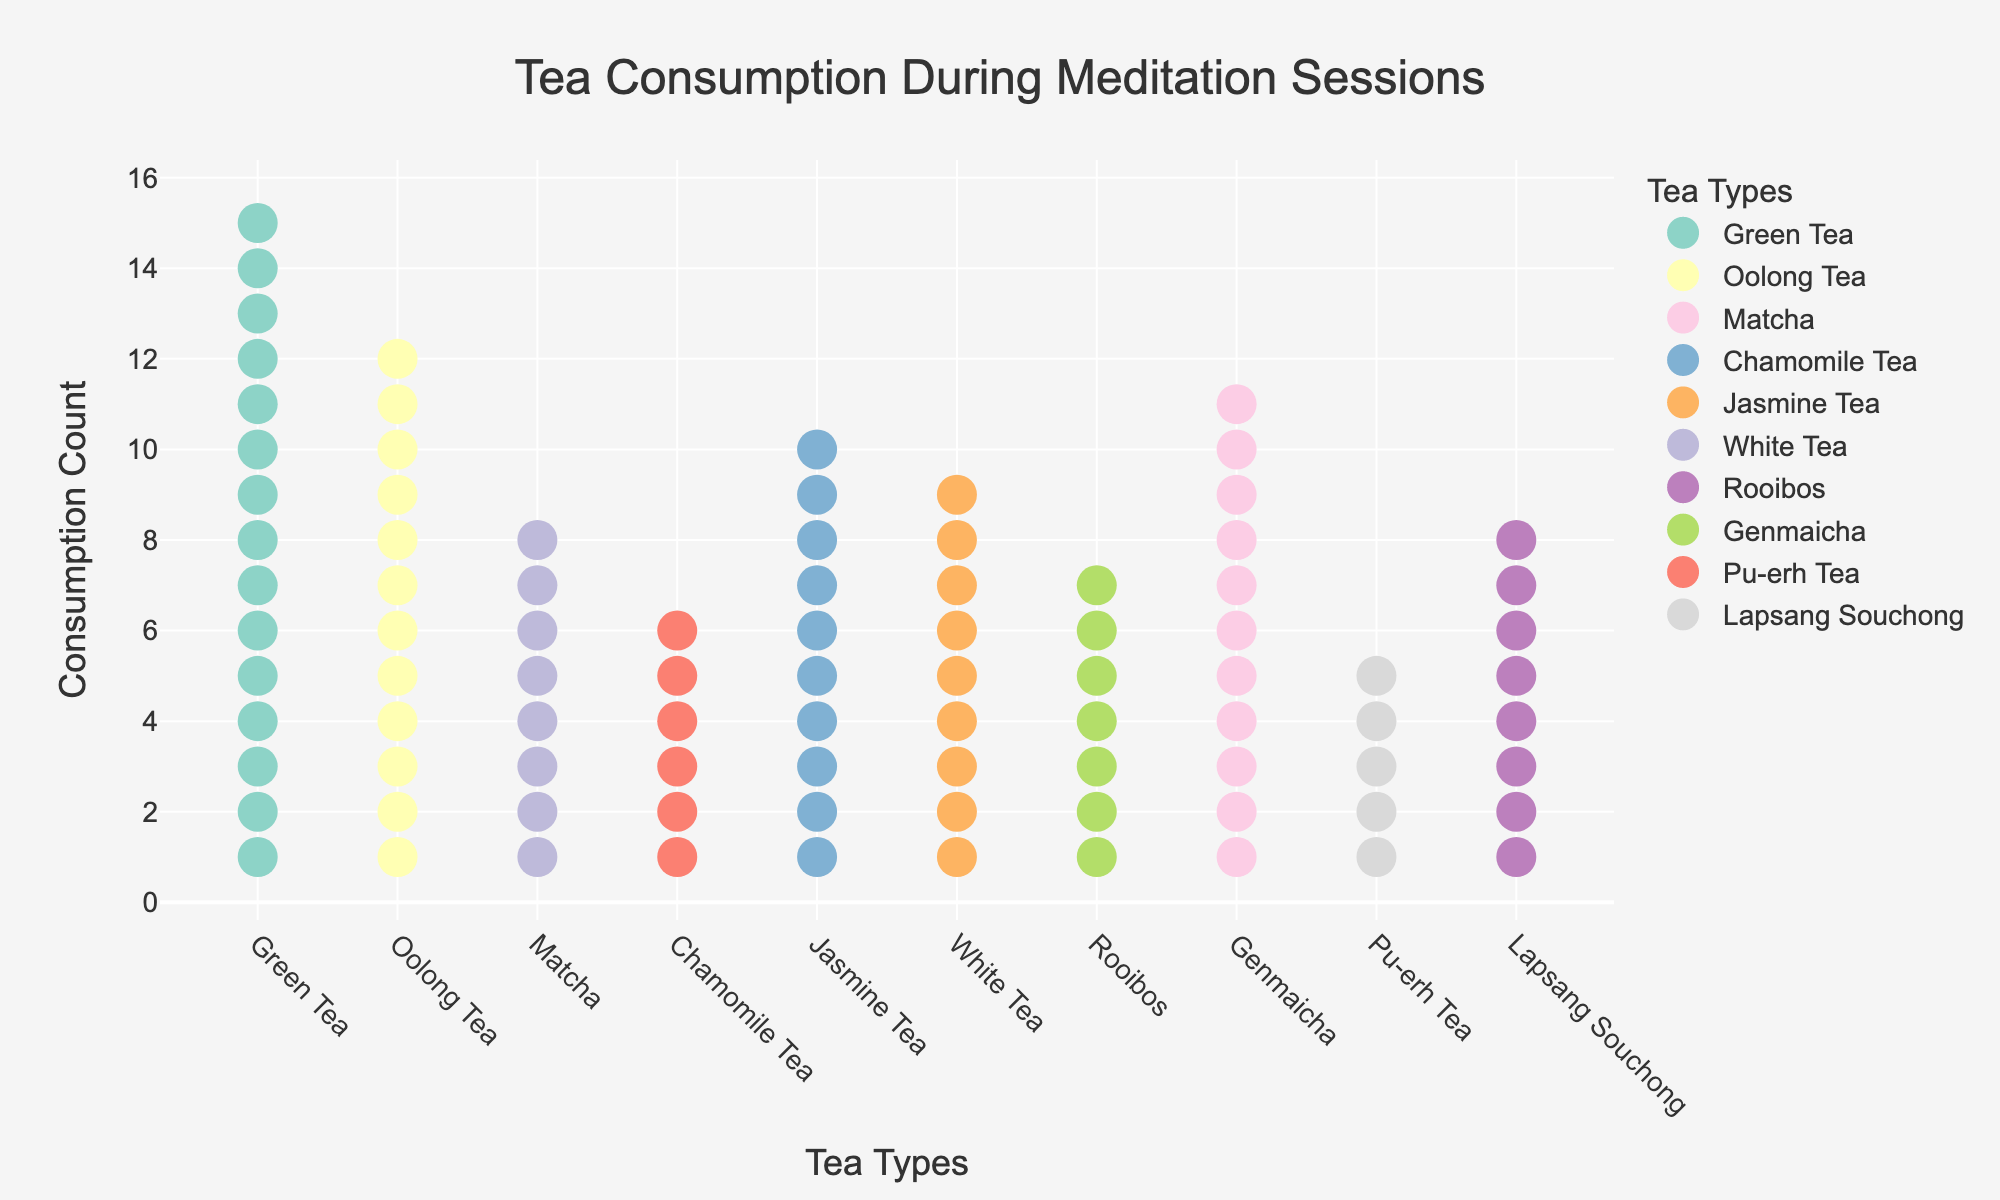What is the title of the plot? The title is written at the top center of the plot. It reads "Tea Consumption During Meditation Sessions".
Answer: Tea Consumption During Meditation Sessions How many types of teas are illustrated in the plot? Count the number of distinct markers along the x-axis, each corresponding to a different tea type. There are 10 markers, representing 10 types of tea.
Answer: 10 Which tea type has the highest consumption count? The tea type with the highest number of markers (circles) in a column is Green Tea with 15 markers.
Answer: Green Tea How do Lapsang Souchong and Genmaicha compare in terms of consumption count? Lapsang Souchong has 5 markers while Genmaicha has 7 markers. Thus, Genmaicha has a higher consumption count by 2 markers.
Answer: Genmaicha has 2 more What is the total consumption count for all tea types? Sum the consumption counts for all tea types: 15 + 12 + 8 + 6 + 10 + 9 + 7 + 11 + 5 + 8. The total is 91.
Answer: 91 Which flavor profile corresponds to the lowest consumption count? Find the tea type with the lowest number of markers. Lapsang Souchong, with 5 markers, corresponds to the "Smoky and Bold" flavor profile.
Answer: Smoky and Bold What is the average consumption count across all tea types? Sum the consumption counts (91) and divide by the number of tea types (10). 91 / 10 = 9.1.
Answer: 9.1 Which tea types have equal consumption counts? Look for columns with the same number of markers. White Tea and Rooibos both have 8 markers.
Answer: White Tea and Rooibos How does the consumption of Matcha compare to Chamomile Tea? Matcha has 11 markers, while Chamomile Tea has 10 markers. Matcha has 1 more marker than Chamomile Tea.
Answer: Matcha has 1 more What flavor profiles are represented by teas with a consumption count greater than 10? Identify tea types with consumption counts greater than 10: Green Tea (Light and Grassy) and Matcha (Umami and Vegetal).
Answer: Light and Grassy, Umami and Vegetal 